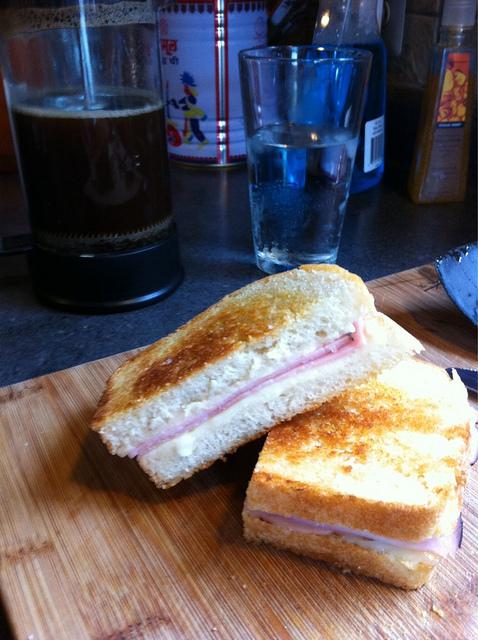What is the name of the container in the background holding coffee? french press 